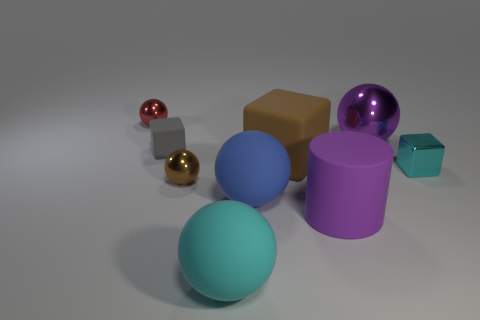There is a gray object that is the same shape as the big brown rubber object; what is it made of?
Provide a succinct answer. Rubber. Does the tiny red thing have the same shape as the tiny object that is to the right of the big cyan rubber sphere?
Your answer should be compact. No. What is the color of the large object that is both behind the large blue rubber sphere and to the left of the big metal object?
Make the answer very short. Brown. Are any large shiny cubes visible?
Your response must be concise. No. Is the number of red balls behind the blue rubber object the same as the number of purple metallic spheres?
Keep it short and to the point. Yes. How many other things are there of the same shape as the big purple matte object?
Ensure brevity in your answer.  0. The red thing has what shape?
Offer a very short reply. Sphere. Is the material of the red thing the same as the brown ball?
Your answer should be compact. Yes. Are there an equal number of large matte spheres behind the tiny gray matte thing and blue matte balls to the right of the big brown thing?
Offer a very short reply. Yes. Are there any cyan metal blocks that are behind the tiny sphere that is behind the tiny metallic sphere in front of the small cyan metallic cube?
Offer a very short reply. No. 